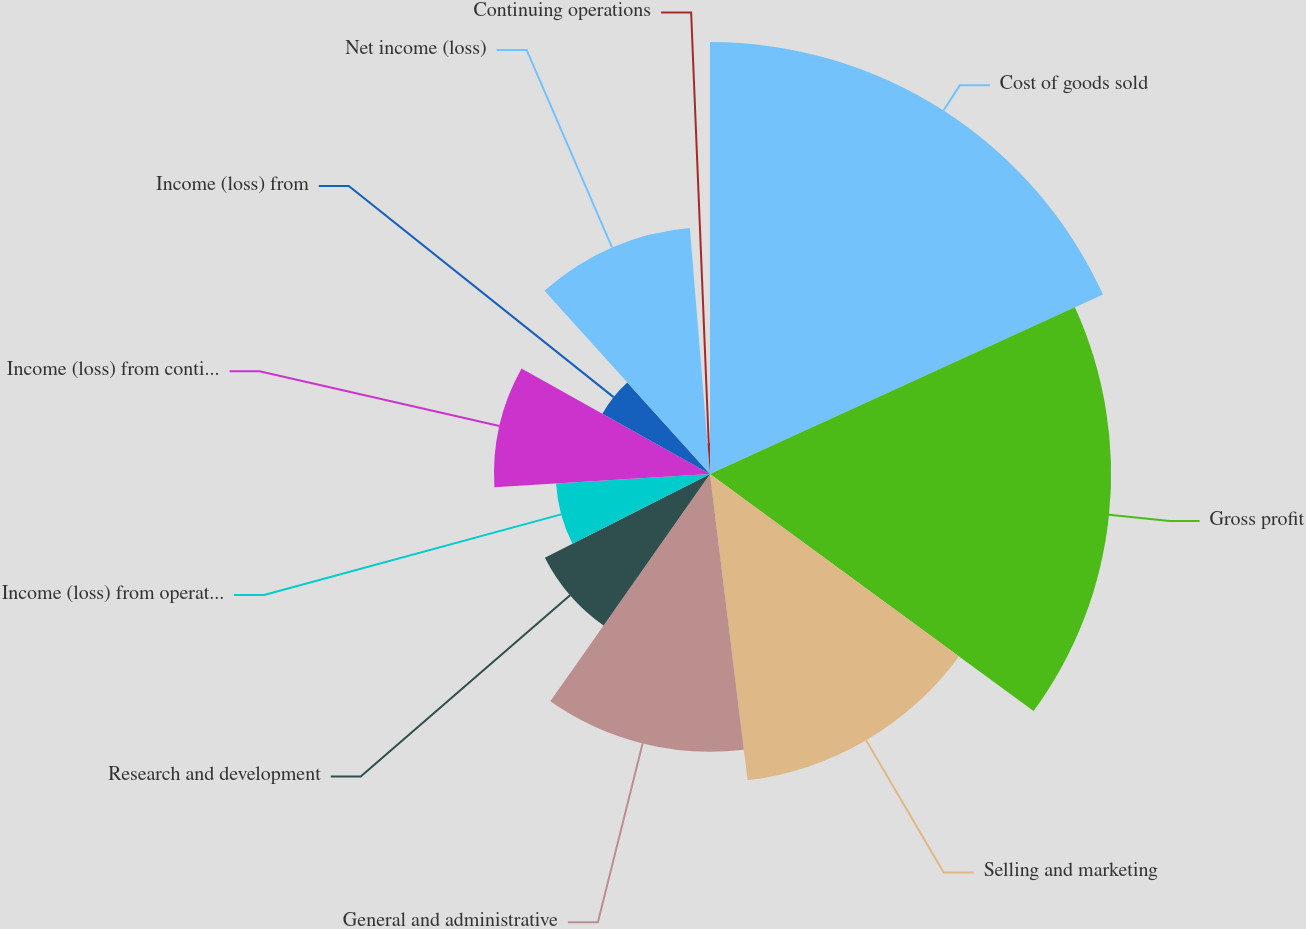Convert chart to OTSL. <chart><loc_0><loc_0><loc_500><loc_500><pie_chart><fcel>Cost of goods sold<fcel>Gross profit<fcel>Selling and marketing<fcel>General and administrative<fcel>Research and development<fcel>Income (loss) from operations<fcel>Income (loss) from continuing<fcel>Income (loss) from<fcel>Net income (loss)<fcel>Continuing operations<nl><fcel>18.18%<fcel>16.88%<fcel>12.99%<fcel>11.69%<fcel>7.79%<fcel>6.49%<fcel>9.09%<fcel>5.19%<fcel>10.39%<fcel>1.3%<nl></chart> 